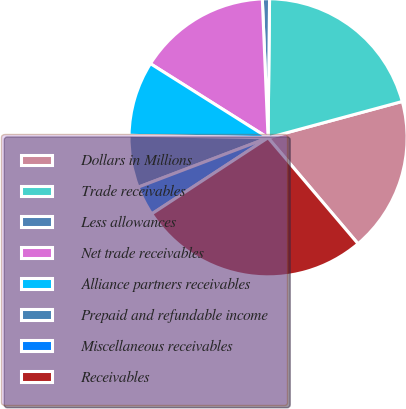<chart> <loc_0><loc_0><loc_500><loc_500><pie_chart><fcel>Dollars in Millions<fcel>Trade receivables<fcel>Less allowances<fcel>Net trade receivables<fcel>Alliance partners receivables<fcel>Prepaid and refundable income<fcel>Miscellaneous receivables<fcel>Receivables<nl><fcel>18.0%<fcel>20.62%<fcel>0.83%<fcel>15.39%<fcel>8.67%<fcel>6.06%<fcel>3.44%<fcel>26.98%<nl></chart> 